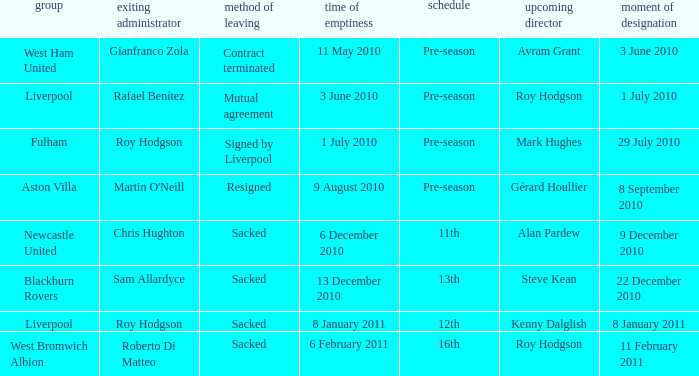How many incoming managers were there after Roy Hodgson left the position for the Fulham team? 1.0. 